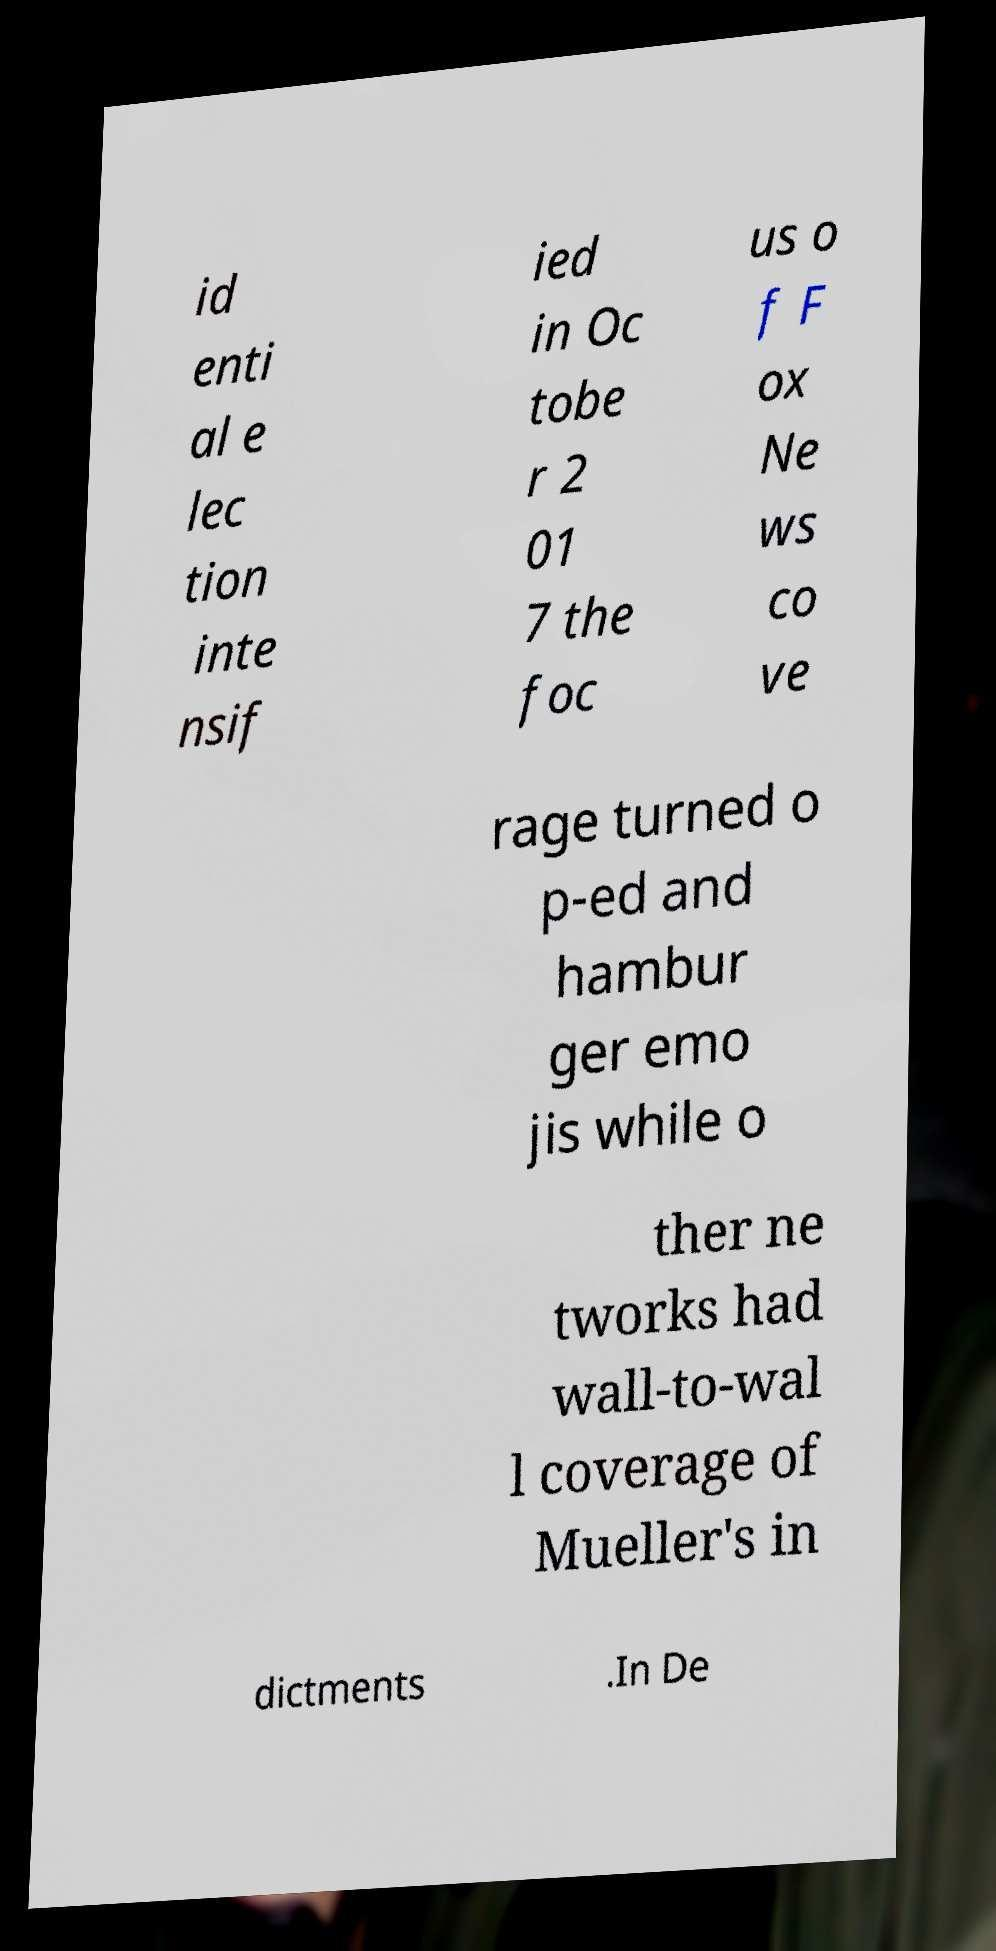Can you accurately transcribe the text from the provided image for me? id enti al e lec tion inte nsif ied in Oc tobe r 2 01 7 the foc us o f F ox Ne ws co ve rage turned o p-ed and hambur ger emo jis while o ther ne tworks had wall-to-wal l coverage of Mueller's in dictments .In De 